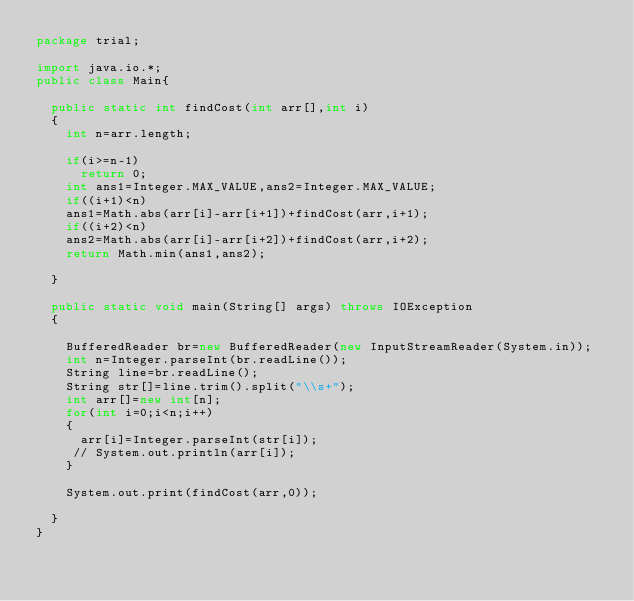Convert code to text. <code><loc_0><loc_0><loc_500><loc_500><_Java_>package trial;

import java.io.*;
public class Main{
 
  public static int findCost(int arr[],int i)
  {
	int n=arr.length;

    if(i>=n-1)
      return 0;
    int ans1=Integer.MAX_VALUE,ans2=Integer.MAX_VALUE;
    if((i+1)<n)
    ans1=Math.abs(arr[i]-arr[i+1])+findCost(arr,i+1);
    if((i+2)<n)
    ans2=Math.abs(arr[i]-arr[i+2])+findCost(arr,i+2);
    return Math.min(ans1,ans2);
    
  }
  
  public static void main(String[] args) throws IOException
  {
     
    BufferedReader br=new BufferedReader(new InputStreamReader(System.in));
    int n=Integer.parseInt(br.readLine());
    String line=br.readLine();
    String str[]=line.trim().split("\\s+");
    int arr[]=new int[n];
    for(int i=0;i<n;i++)
    {
      arr[i]=Integer.parseInt(str[i]);
     // System.out.println(arr[i]);
    }
    
    System.out.print(findCost(arr,0));
    
  }
}</code> 